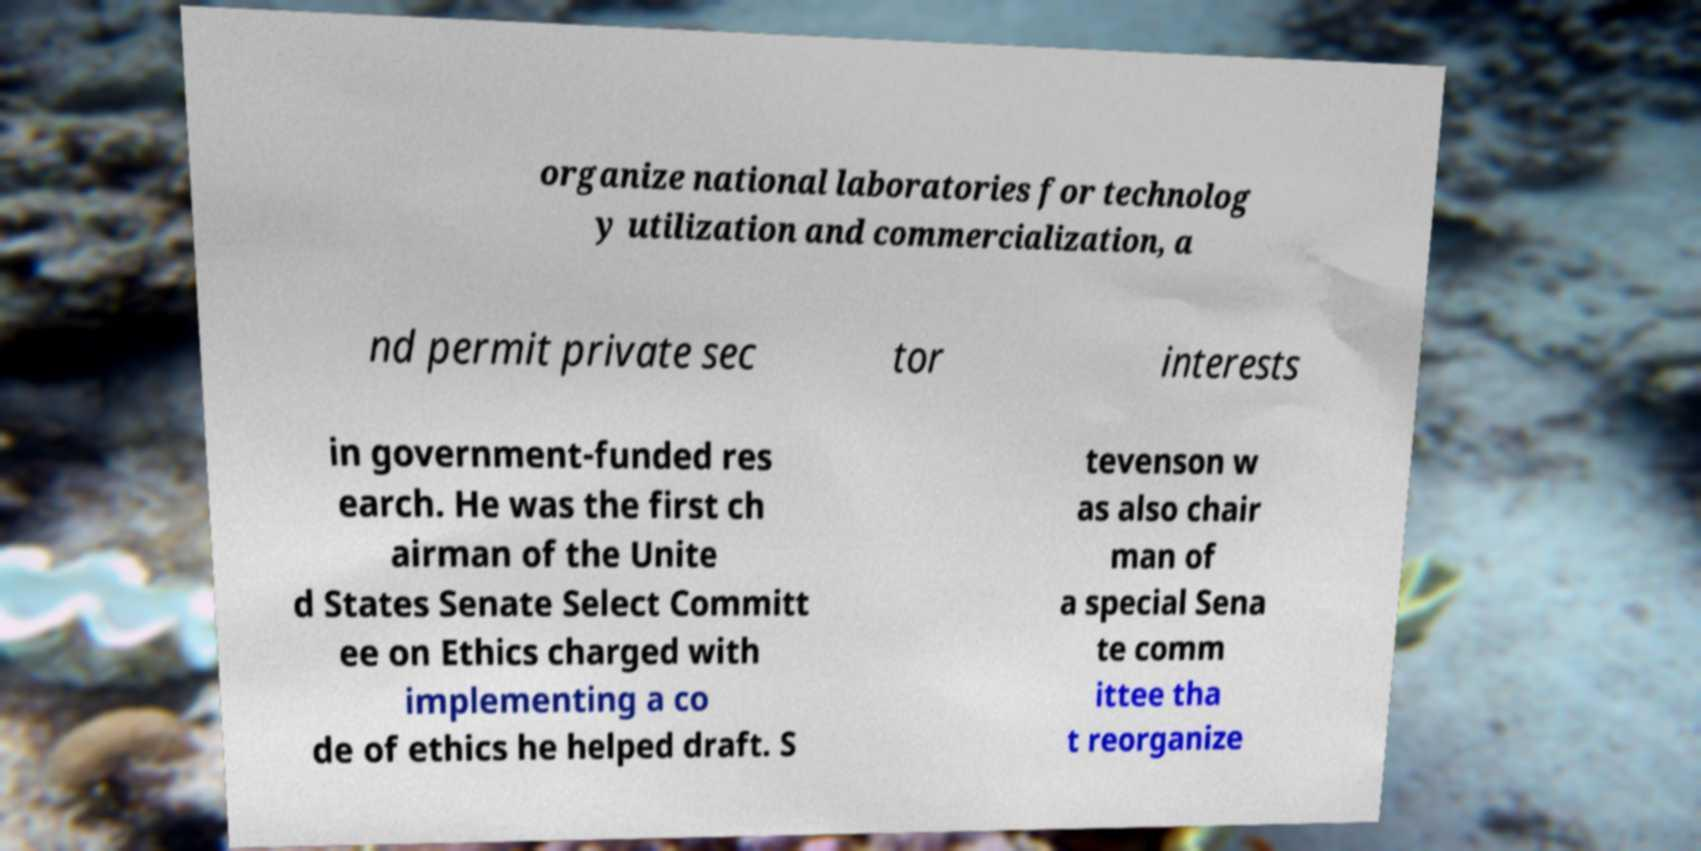Can you read and provide the text displayed in the image?This photo seems to have some interesting text. Can you extract and type it out for me? organize national laboratories for technolog y utilization and commercialization, a nd permit private sec tor interests in government-funded res earch. He was the first ch airman of the Unite d States Senate Select Committ ee on Ethics charged with implementing a co de of ethics he helped draft. S tevenson w as also chair man of a special Sena te comm ittee tha t reorganize 